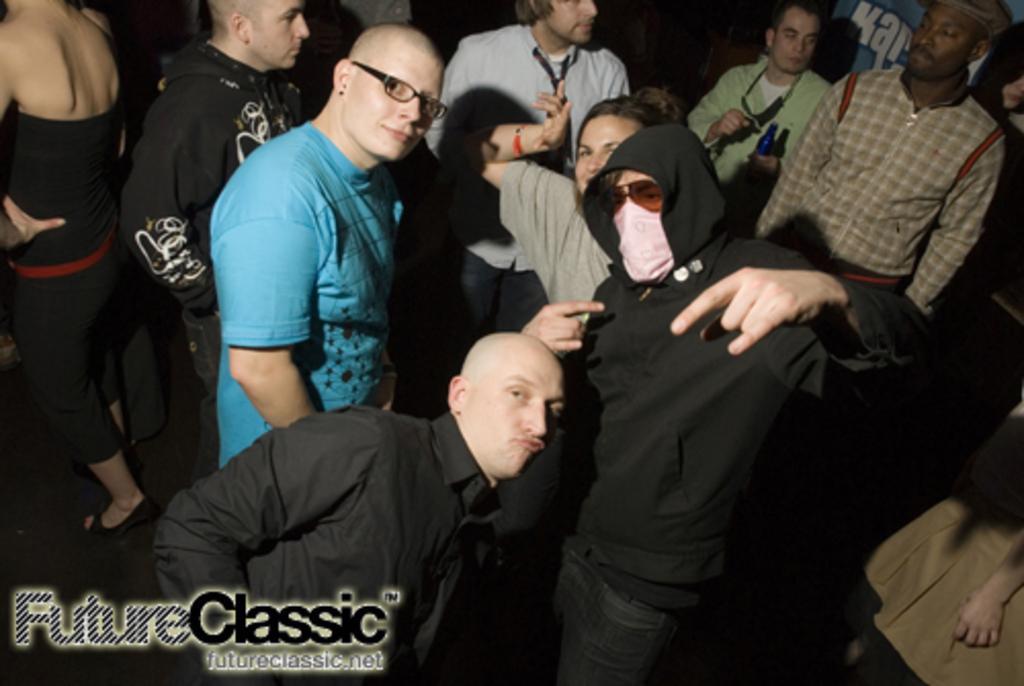Can you describe this image briefly? In this picture I can see some people are in one place, among them few people are wearing spectacles. 